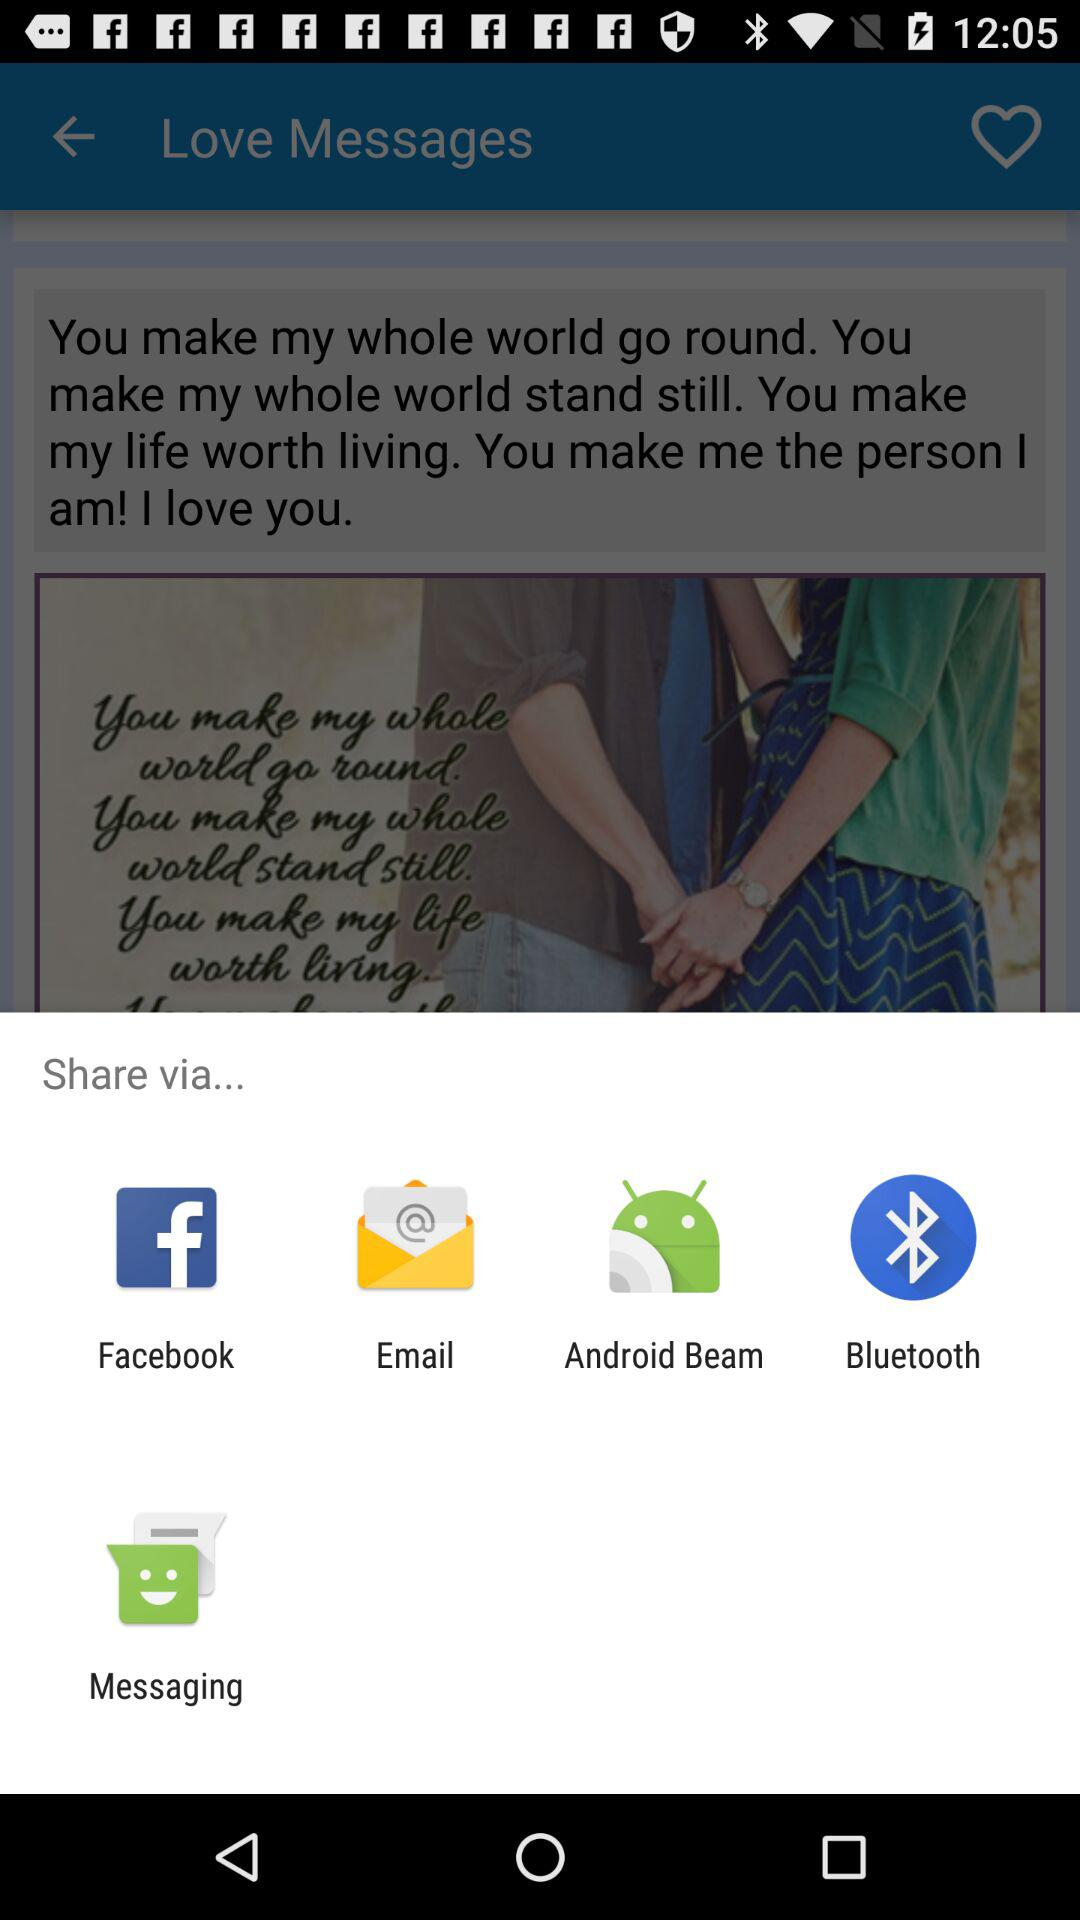Through which application can it be shared? It can be shared through "Facebook", "Email", "Android Beam", "Bluetooth" and "Messaging". 